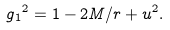<formula> <loc_0><loc_0><loc_500><loc_500>g { _ { 1 } } ^ { 2 } = 1 - 2 M / r + u ^ { 2 } .</formula> 